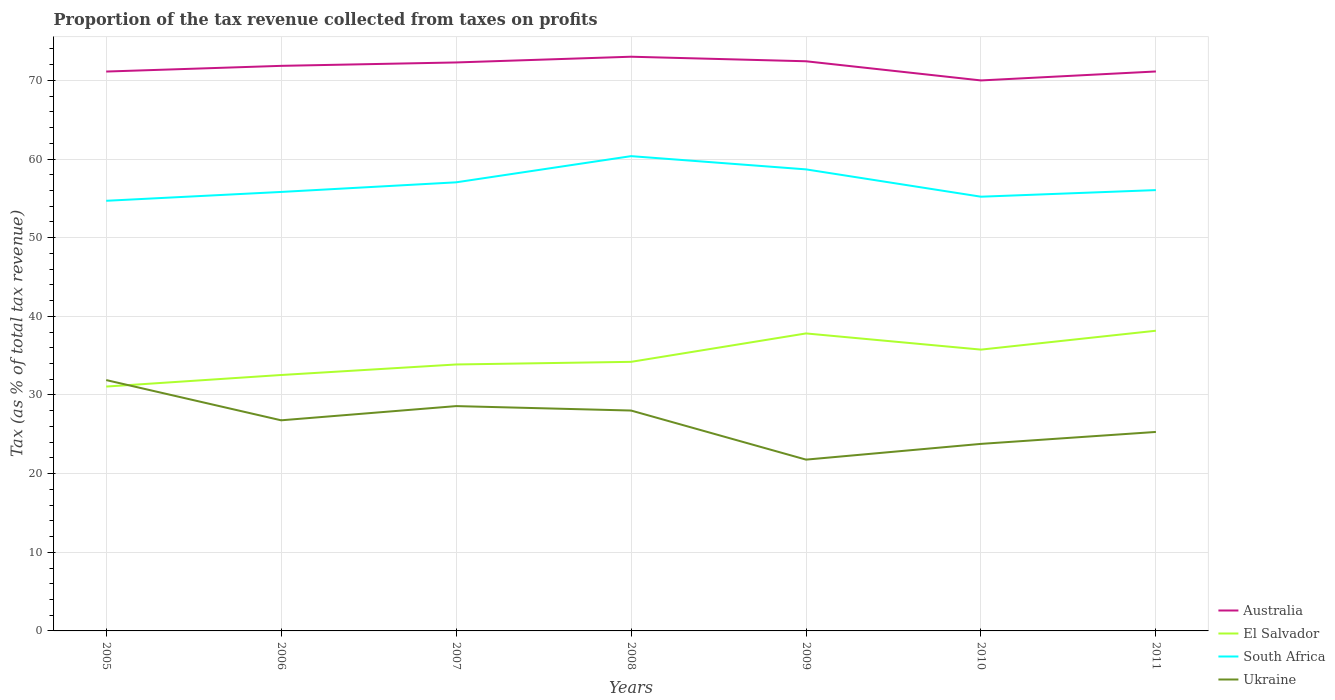How many different coloured lines are there?
Your answer should be very brief. 4. Across all years, what is the maximum proportion of the tax revenue collected in Australia?
Provide a succinct answer. 70. What is the total proportion of the tax revenue collected in El Salvador in the graph?
Your response must be concise. -5.63. What is the difference between the highest and the second highest proportion of the tax revenue collected in Australia?
Your answer should be compact. 3.01. Is the proportion of the tax revenue collected in Australia strictly greater than the proportion of the tax revenue collected in Ukraine over the years?
Your answer should be compact. No. Are the values on the major ticks of Y-axis written in scientific E-notation?
Provide a succinct answer. No. Does the graph contain grids?
Offer a very short reply. Yes. What is the title of the graph?
Your answer should be compact. Proportion of the tax revenue collected from taxes on profits. Does "Cabo Verde" appear as one of the legend labels in the graph?
Make the answer very short. No. What is the label or title of the Y-axis?
Your answer should be compact. Tax (as % of total tax revenue). What is the Tax (as % of total tax revenue) of Australia in 2005?
Keep it short and to the point. 71.13. What is the Tax (as % of total tax revenue) in El Salvador in 2005?
Make the answer very short. 31.07. What is the Tax (as % of total tax revenue) in South Africa in 2005?
Keep it short and to the point. 54.69. What is the Tax (as % of total tax revenue) in Ukraine in 2005?
Provide a succinct answer. 31.9. What is the Tax (as % of total tax revenue) of Australia in 2006?
Make the answer very short. 71.85. What is the Tax (as % of total tax revenue) of El Salvador in 2006?
Your answer should be compact. 32.54. What is the Tax (as % of total tax revenue) of South Africa in 2006?
Your answer should be compact. 55.82. What is the Tax (as % of total tax revenue) of Ukraine in 2006?
Keep it short and to the point. 26.78. What is the Tax (as % of total tax revenue) of Australia in 2007?
Provide a succinct answer. 72.28. What is the Tax (as % of total tax revenue) of El Salvador in 2007?
Provide a short and direct response. 33.88. What is the Tax (as % of total tax revenue) of South Africa in 2007?
Offer a terse response. 57.04. What is the Tax (as % of total tax revenue) in Ukraine in 2007?
Offer a terse response. 28.59. What is the Tax (as % of total tax revenue) in Australia in 2008?
Provide a short and direct response. 73.01. What is the Tax (as % of total tax revenue) in El Salvador in 2008?
Offer a terse response. 34.21. What is the Tax (as % of total tax revenue) in South Africa in 2008?
Ensure brevity in your answer.  60.37. What is the Tax (as % of total tax revenue) of Ukraine in 2008?
Your answer should be very brief. 28.02. What is the Tax (as % of total tax revenue) in Australia in 2009?
Offer a terse response. 72.43. What is the Tax (as % of total tax revenue) of El Salvador in 2009?
Offer a terse response. 37.83. What is the Tax (as % of total tax revenue) in South Africa in 2009?
Your answer should be very brief. 58.69. What is the Tax (as % of total tax revenue) of Ukraine in 2009?
Your answer should be compact. 21.78. What is the Tax (as % of total tax revenue) in Australia in 2010?
Offer a terse response. 70. What is the Tax (as % of total tax revenue) of El Salvador in 2010?
Give a very brief answer. 35.77. What is the Tax (as % of total tax revenue) in South Africa in 2010?
Provide a short and direct response. 55.21. What is the Tax (as % of total tax revenue) in Ukraine in 2010?
Your response must be concise. 23.78. What is the Tax (as % of total tax revenue) in Australia in 2011?
Ensure brevity in your answer.  71.14. What is the Tax (as % of total tax revenue) of El Salvador in 2011?
Provide a succinct answer. 38.17. What is the Tax (as % of total tax revenue) of South Africa in 2011?
Your answer should be compact. 56.05. What is the Tax (as % of total tax revenue) of Ukraine in 2011?
Give a very brief answer. 25.3. Across all years, what is the maximum Tax (as % of total tax revenue) in Australia?
Provide a succinct answer. 73.01. Across all years, what is the maximum Tax (as % of total tax revenue) of El Salvador?
Keep it short and to the point. 38.17. Across all years, what is the maximum Tax (as % of total tax revenue) of South Africa?
Your response must be concise. 60.37. Across all years, what is the maximum Tax (as % of total tax revenue) in Ukraine?
Your response must be concise. 31.9. Across all years, what is the minimum Tax (as % of total tax revenue) in Australia?
Provide a succinct answer. 70. Across all years, what is the minimum Tax (as % of total tax revenue) in El Salvador?
Keep it short and to the point. 31.07. Across all years, what is the minimum Tax (as % of total tax revenue) of South Africa?
Offer a very short reply. 54.69. Across all years, what is the minimum Tax (as % of total tax revenue) in Ukraine?
Your answer should be very brief. 21.78. What is the total Tax (as % of total tax revenue) in Australia in the graph?
Your answer should be compact. 501.84. What is the total Tax (as % of total tax revenue) in El Salvador in the graph?
Make the answer very short. 243.48. What is the total Tax (as % of total tax revenue) in South Africa in the graph?
Provide a short and direct response. 397.88. What is the total Tax (as % of total tax revenue) in Ukraine in the graph?
Your answer should be compact. 186.15. What is the difference between the Tax (as % of total tax revenue) of Australia in 2005 and that in 2006?
Provide a succinct answer. -0.72. What is the difference between the Tax (as % of total tax revenue) in El Salvador in 2005 and that in 2006?
Your answer should be very brief. -1.47. What is the difference between the Tax (as % of total tax revenue) in South Africa in 2005 and that in 2006?
Make the answer very short. -1.13. What is the difference between the Tax (as % of total tax revenue) in Ukraine in 2005 and that in 2006?
Ensure brevity in your answer.  5.12. What is the difference between the Tax (as % of total tax revenue) of Australia in 2005 and that in 2007?
Provide a short and direct response. -1.16. What is the difference between the Tax (as % of total tax revenue) of El Salvador in 2005 and that in 2007?
Offer a very short reply. -2.81. What is the difference between the Tax (as % of total tax revenue) in South Africa in 2005 and that in 2007?
Offer a very short reply. -2.35. What is the difference between the Tax (as % of total tax revenue) in Ukraine in 2005 and that in 2007?
Make the answer very short. 3.31. What is the difference between the Tax (as % of total tax revenue) in Australia in 2005 and that in 2008?
Give a very brief answer. -1.89. What is the difference between the Tax (as % of total tax revenue) in El Salvador in 2005 and that in 2008?
Provide a succinct answer. -3.14. What is the difference between the Tax (as % of total tax revenue) of South Africa in 2005 and that in 2008?
Offer a very short reply. -5.68. What is the difference between the Tax (as % of total tax revenue) in Ukraine in 2005 and that in 2008?
Provide a short and direct response. 3.87. What is the difference between the Tax (as % of total tax revenue) in Australia in 2005 and that in 2009?
Provide a short and direct response. -1.31. What is the difference between the Tax (as % of total tax revenue) of El Salvador in 2005 and that in 2009?
Your answer should be very brief. -6.76. What is the difference between the Tax (as % of total tax revenue) in South Africa in 2005 and that in 2009?
Your answer should be compact. -3.99. What is the difference between the Tax (as % of total tax revenue) in Ukraine in 2005 and that in 2009?
Offer a terse response. 10.12. What is the difference between the Tax (as % of total tax revenue) in Australia in 2005 and that in 2010?
Make the answer very short. 1.13. What is the difference between the Tax (as % of total tax revenue) of El Salvador in 2005 and that in 2010?
Make the answer very short. -4.7. What is the difference between the Tax (as % of total tax revenue) of South Africa in 2005 and that in 2010?
Make the answer very short. -0.52. What is the difference between the Tax (as % of total tax revenue) of Ukraine in 2005 and that in 2010?
Ensure brevity in your answer.  8.11. What is the difference between the Tax (as % of total tax revenue) of Australia in 2005 and that in 2011?
Keep it short and to the point. -0.01. What is the difference between the Tax (as % of total tax revenue) in El Salvador in 2005 and that in 2011?
Give a very brief answer. -7.1. What is the difference between the Tax (as % of total tax revenue) in South Africa in 2005 and that in 2011?
Offer a very short reply. -1.36. What is the difference between the Tax (as % of total tax revenue) in Ukraine in 2005 and that in 2011?
Ensure brevity in your answer.  6.6. What is the difference between the Tax (as % of total tax revenue) of Australia in 2006 and that in 2007?
Ensure brevity in your answer.  -0.43. What is the difference between the Tax (as % of total tax revenue) of El Salvador in 2006 and that in 2007?
Ensure brevity in your answer.  -1.34. What is the difference between the Tax (as % of total tax revenue) of South Africa in 2006 and that in 2007?
Offer a very short reply. -1.22. What is the difference between the Tax (as % of total tax revenue) of Ukraine in 2006 and that in 2007?
Your answer should be very brief. -1.81. What is the difference between the Tax (as % of total tax revenue) of Australia in 2006 and that in 2008?
Make the answer very short. -1.16. What is the difference between the Tax (as % of total tax revenue) of El Salvador in 2006 and that in 2008?
Provide a succinct answer. -1.67. What is the difference between the Tax (as % of total tax revenue) of South Africa in 2006 and that in 2008?
Your answer should be compact. -4.55. What is the difference between the Tax (as % of total tax revenue) of Ukraine in 2006 and that in 2008?
Give a very brief answer. -1.24. What is the difference between the Tax (as % of total tax revenue) in Australia in 2006 and that in 2009?
Give a very brief answer. -0.58. What is the difference between the Tax (as % of total tax revenue) in El Salvador in 2006 and that in 2009?
Provide a succinct answer. -5.28. What is the difference between the Tax (as % of total tax revenue) of South Africa in 2006 and that in 2009?
Your answer should be compact. -2.87. What is the difference between the Tax (as % of total tax revenue) in Ukraine in 2006 and that in 2009?
Your answer should be very brief. 5. What is the difference between the Tax (as % of total tax revenue) of Australia in 2006 and that in 2010?
Keep it short and to the point. 1.85. What is the difference between the Tax (as % of total tax revenue) in El Salvador in 2006 and that in 2010?
Give a very brief answer. -3.23. What is the difference between the Tax (as % of total tax revenue) of South Africa in 2006 and that in 2010?
Your response must be concise. 0.61. What is the difference between the Tax (as % of total tax revenue) of Ukraine in 2006 and that in 2010?
Your answer should be very brief. 3. What is the difference between the Tax (as % of total tax revenue) in Australia in 2006 and that in 2011?
Provide a succinct answer. 0.71. What is the difference between the Tax (as % of total tax revenue) in El Salvador in 2006 and that in 2011?
Keep it short and to the point. -5.63. What is the difference between the Tax (as % of total tax revenue) in South Africa in 2006 and that in 2011?
Your answer should be compact. -0.23. What is the difference between the Tax (as % of total tax revenue) in Ukraine in 2006 and that in 2011?
Provide a short and direct response. 1.48. What is the difference between the Tax (as % of total tax revenue) in Australia in 2007 and that in 2008?
Provide a succinct answer. -0.73. What is the difference between the Tax (as % of total tax revenue) of El Salvador in 2007 and that in 2008?
Ensure brevity in your answer.  -0.33. What is the difference between the Tax (as % of total tax revenue) in South Africa in 2007 and that in 2008?
Your answer should be compact. -3.33. What is the difference between the Tax (as % of total tax revenue) of Ukraine in 2007 and that in 2008?
Give a very brief answer. 0.56. What is the difference between the Tax (as % of total tax revenue) of Australia in 2007 and that in 2009?
Offer a very short reply. -0.15. What is the difference between the Tax (as % of total tax revenue) of El Salvador in 2007 and that in 2009?
Provide a short and direct response. -3.95. What is the difference between the Tax (as % of total tax revenue) of South Africa in 2007 and that in 2009?
Ensure brevity in your answer.  -1.65. What is the difference between the Tax (as % of total tax revenue) in Ukraine in 2007 and that in 2009?
Keep it short and to the point. 6.81. What is the difference between the Tax (as % of total tax revenue) of Australia in 2007 and that in 2010?
Your answer should be compact. 2.29. What is the difference between the Tax (as % of total tax revenue) of El Salvador in 2007 and that in 2010?
Make the answer very short. -1.89. What is the difference between the Tax (as % of total tax revenue) in South Africa in 2007 and that in 2010?
Make the answer very short. 1.83. What is the difference between the Tax (as % of total tax revenue) of Ukraine in 2007 and that in 2010?
Keep it short and to the point. 4.8. What is the difference between the Tax (as % of total tax revenue) in Australia in 2007 and that in 2011?
Your answer should be compact. 1.15. What is the difference between the Tax (as % of total tax revenue) in El Salvador in 2007 and that in 2011?
Give a very brief answer. -4.29. What is the difference between the Tax (as % of total tax revenue) of South Africa in 2007 and that in 2011?
Your response must be concise. 0.99. What is the difference between the Tax (as % of total tax revenue) of Ukraine in 2007 and that in 2011?
Ensure brevity in your answer.  3.29. What is the difference between the Tax (as % of total tax revenue) in Australia in 2008 and that in 2009?
Give a very brief answer. 0.58. What is the difference between the Tax (as % of total tax revenue) in El Salvador in 2008 and that in 2009?
Ensure brevity in your answer.  -3.61. What is the difference between the Tax (as % of total tax revenue) of South Africa in 2008 and that in 2009?
Keep it short and to the point. 1.68. What is the difference between the Tax (as % of total tax revenue) in Ukraine in 2008 and that in 2009?
Offer a terse response. 6.24. What is the difference between the Tax (as % of total tax revenue) of Australia in 2008 and that in 2010?
Ensure brevity in your answer.  3.01. What is the difference between the Tax (as % of total tax revenue) in El Salvador in 2008 and that in 2010?
Your answer should be compact. -1.56. What is the difference between the Tax (as % of total tax revenue) in South Africa in 2008 and that in 2010?
Provide a short and direct response. 5.16. What is the difference between the Tax (as % of total tax revenue) of Ukraine in 2008 and that in 2010?
Provide a succinct answer. 4.24. What is the difference between the Tax (as % of total tax revenue) of Australia in 2008 and that in 2011?
Give a very brief answer. 1.87. What is the difference between the Tax (as % of total tax revenue) of El Salvador in 2008 and that in 2011?
Provide a succinct answer. -3.96. What is the difference between the Tax (as % of total tax revenue) in South Africa in 2008 and that in 2011?
Your answer should be compact. 4.32. What is the difference between the Tax (as % of total tax revenue) in Ukraine in 2008 and that in 2011?
Your answer should be very brief. 2.72. What is the difference between the Tax (as % of total tax revenue) of Australia in 2009 and that in 2010?
Your response must be concise. 2.44. What is the difference between the Tax (as % of total tax revenue) of El Salvador in 2009 and that in 2010?
Provide a succinct answer. 2.06. What is the difference between the Tax (as % of total tax revenue) in South Africa in 2009 and that in 2010?
Offer a very short reply. 3.47. What is the difference between the Tax (as % of total tax revenue) of Ukraine in 2009 and that in 2010?
Your answer should be very brief. -2. What is the difference between the Tax (as % of total tax revenue) of Australia in 2009 and that in 2011?
Your answer should be compact. 1.3. What is the difference between the Tax (as % of total tax revenue) of El Salvador in 2009 and that in 2011?
Offer a very short reply. -0.34. What is the difference between the Tax (as % of total tax revenue) in South Africa in 2009 and that in 2011?
Provide a succinct answer. 2.63. What is the difference between the Tax (as % of total tax revenue) of Ukraine in 2009 and that in 2011?
Make the answer very short. -3.52. What is the difference between the Tax (as % of total tax revenue) in Australia in 2010 and that in 2011?
Your answer should be very brief. -1.14. What is the difference between the Tax (as % of total tax revenue) in El Salvador in 2010 and that in 2011?
Keep it short and to the point. -2.4. What is the difference between the Tax (as % of total tax revenue) in South Africa in 2010 and that in 2011?
Offer a terse response. -0.84. What is the difference between the Tax (as % of total tax revenue) in Ukraine in 2010 and that in 2011?
Ensure brevity in your answer.  -1.52. What is the difference between the Tax (as % of total tax revenue) of Australia in 2005 and the Tax (as % of total tax revenue) of El Salvador in 2006?
Provide a succinct answer. 38.58. What is the difference between the Tax (as % of total tax revenue) in Australia in 2005 and the Tax (as % of total tax revenue) in South Africa in 2006?
Make the answer very short. 15.31. What is the difference between the Tax (as % of total tax revenue) of Australia in 2005 and the Tax (as % of total tax revenue) of Ukraine in 2006?
Keep it short and to the point. 44.35. What is the difference between the Tax (as % of total tax revenue) in El Salvador in 2005 and the Tax (as % of total tax revenue) in South Africa in 2006?
Your response must be concise. -24.75. What is the difference between the Tax (as % of total tax revenue) of El Salvador in 2005 and the Tax (as % of total tax revenue) of Ukraine in 2006?
Your answer should be compact. 4.29. What is the difference between the Tax (as % of total tax revenue) in South Africa in 2005 and the Tax (as % of total tax revenue) in Ukraine in 2006?
Ensure brevity in your answer.  27.91. What is the difference between the Tax (as % of total tax revenue) of Australia in 2005 and the Tax (as % of total tax revenue) of El Salvador in 2007?
Keep it short and to the point. 37.25. What is the difference between the Tax (as % of total tax revenue) in Australia in 2005 and the Tax (as % of total tax revenue) in South Africa in 2007?
Ensure brevity in your answer.  14.09. What is the difference between the Tax (as % of total tax revenue) of Australia in 2005 and the Tax (as % of total tax revenue) of Ukraine in 2007?
Offer a terse response. 42.54. What is the difference between the Tax (as % of total tax revenue) of El Salvador in 2005 and the Tax (as % of total tax revenue) of South Africa in 2007?
Give a very brief answer. -25.97. What is the difference between the Tax (as % of total tax revenue) of El Salvador in 2005 and the Tax (as % of total tax revenue) of Ukraine in 2007?
Offer a very short reply. 2.48. What is the difference between the Tax (as % of total tax revenue) of South Africa in 2005 and the Tax (as % of total tax revenue) of Ukraine in 2007?
Provide a succinct answer. 26.11. What is the difference between the Tax (as % of total tax revenue) of Australia in 2005 and the Tax (as % of total tax revenue) of El Salvador in 2008?
Offer a terse response. 36.91. What is the difference between the Tax (as % of total tax revenue) of Australia in 2005 and the Tax (as % of total tax revenue) of South Africa in 2008?
Give a very brief answer. 10.76. What is the difference between the Tax (as % of total tax revenue) in Australia in 2005 and the Tax (as % of total tax revenue) in Ukraine in 2008?
Offer a very short reply. 43.1. What is the difference between the Tax (as % of total tax revenue) of El Salvador in 2005 and the Tax (as % of total tax revenue) of South Africa in 2008?
Ensure brevity in your answer.  -29.3. What is the difference between the Tax (as % of total tax revenue) in El Salvador in 2005 and the Tax (as % of total tax revenue) in Ukraine in 2008?
Your answer should be very brief. 3.05. What is the difference between the Tax (as % of total tax revenue) in South Africa in 2005 and the Tax (as % of total tax revenue) in Ukraine in 2008?
Keep it short and to the point. 26.67. What is the difference between the Tax (as % of total tax revenue) in Australia in 2005 and the Tax (as % of total tax revenue) in El Salvador in 2009?
Your response must be concise. 33.3. What is the difference between the Tax (as % of total tax revenue) in Australia in 2005 and the Tax (as % of total tax revenue) in South Africa in 2009?
Keep it short and to the point. 12.44. What is the difference between the Tax (as % of total tax revenue) of Australia in 2005 and the Tax (as % of total tax revenue) of Ukraine in 2009?
Your answer should be very brief. 49.35. What is the difference between the Tax (as % of total tax revenue) in El Salvador in 2005 and the Tax (as % of total tax revenue) in South Africa in 2009?
Offer a very short reply. -27.62. What is the difference between the Tax (as % of total tax revenue) of El Salvador in 2005 and the Tax (as % of total tax revenue) of Ukraine in 2009?
Your response must be concise. 9.29. What is the difference between the Tax (as % of total tax revenue) of South Africa in 2005 and the Tax (as % of total tax revenue) of Ukraine in 2009?
Provide a succinct answer. 32.91. What is the difference between the Tax (as % of total tax revenue) in Australia in 2005 and the Tax (as % of total tax revenue) in El Salvador in 2010?
Your answer should be compact. 35.36. What is the difference between the Tax (as % of total tax revenue) of Australia in 2005 and the Tax (as % of total tax revenue) of South Africa in 2010?
Your answer should be compact. 15.91. What is the difference between the Tax (as % of total tax revenue) of Australia in 2005 and the Tax (as % of total tax revenue) of Ukraine in 2010?
Provide a short and direct response. 47.34. What is the difference between the Tax (as % of total tax revenue) in El Salvador in 2005 and the Tax (as % of total tax revenue) in South Africa in 2010?
Give a very brief answer. -24.14. What is the difference between the Tax (as % of total tax revenue) of El Salvador in 2005 and the Tax (as % of total tax revenue) of Ukraine in 2010?
Offer a terse response. 7.29. What is the difference between the Tax (as % of total tax revenue) of South Africa in 2005 and the Tax (as % of total tax revenue) of Ukraine in 2010?
Give a very brief answer. 30.91. What is the difference between the Tax (as % of total tax revenue) in Australia in 2005 and the Tax (as % of total tax revenue) in El Salvador in 2011?
Provide a succinct answer. 32.96. What is the difference between the Tax (as % of total tax revenue) in Australia in 2005 and the Tax (as % of total tax revenue) in South Africa in 2011?
Provide a succinct answer. 15.07. What is the difference between the Tax (as % of total tax revenue) in Australia in 2005 and the Tax (as % of total tax revenue) in Ukraine in 2011?
Make the answer very short. 45.83. What is the difference between the Tax (as % of total tax revenue) in El Salvador in 2005 and the Tax (as % of total tax revenue) in South Africa in 2011?
Keep it short and to the point. -24.98. What is the difference between the Tax (as % of total tax revenue) of El Salvador in 2005 and the Tax (as % of total tax revenue) of Ukraine in 2011?
Give a very brief answer. 5.77. What is the difference between the Tax (as % of total tax revenue) of South Africa in 2005 and the Tax (as % of total tax revenue) of Ukraine in 2011?
Provide a succinct answer. 29.39. What is the difference between the Tax (as % of total tax revenue) of Australia in 2006 and the Tax (as % of total tax revenue) of El Salvador in 2007?
Provide a short and direct response. 37.97. What is the difference between the Tax (as % of total tax revenue) of Australia in 2006 and the Tax (as % of total tax revenue) of South Africa in 2007?
Ensure brevity in your answer.  14.81. What is the difference between the Tax (as % of total tax revenue) of Australia in 2006 and the Tax (as % of total tax revenue) of Ukraine in 2007?
Your answer should be compact. 43.26. What is the difference between the Tax (as % of total tax revenue) in El Salvador in 2006 and the Tax (as % of total tax revenue) in South Africa in 2007?
Provide a succinct answer. -24.5. What is the difference between the Tax (as % of total tax revenue) in El Salvador in 2006 and the Tax (as % of total tax revenue) in Ukraine in 2007?
Make the answer very short. 3.96. What is the difference between the Tax (as % of total tax revenue) of South Africa in 2006 and the Tax (as % of total tax revenue) of Ukraine in 2007?
Give a very brief answer. 27.23. What is the difference between the Tax (as % of total tax revenue) in Australia in 2006 and the Tax (as % of total tax revenue) in El Salvador in 2008?
Keep it short and to the point. 37.64. What is the difference between the Tax (as % of total tax revenue) of Australia in 2006 and the Tax (as % of total tax revenue) of South Africa in 2008?
Provide a short and direct response. 11.48. What is the difference between the Tax (as % of total tax revenue) of Australia in 2006 and the Tax (as % of total tax revenue) of Ukraine in 2008?
Make the answer very short. 43.83. What is the difference between the Tax (as % of total tax revenue) of El Salvador in 2006 and the Tax (as % of total tax revenue) of South Africa in 2008?
Your response must be concise. -27.83. What is the difference between the Tax (as % of total tax revenue) in El Salvador in 2006 and the Tax (as % of total tax revenue) in Ukraine in 2008?
Your response must be concise. 4.52. What is the difference between the Tax (as % of total tax revenue) in South Africa in 2006 and the Tax (as % of total tax revenue) in Ukraine in 2008?
Your response must be concise. 27.8. What is the difference between the Tax (as % of total tax revenue) in Australia in 2006 and the Tax (as % of total tax revenue) in El Salvador in 2009?
Offer a very short reply. 34.02. What is the difference between the Tax (as % of total tax revenue) of Australia in 2006 and the Tax (as % of total tax revenue) of South Africa in 2009?
Give a very brief answer. 13.16. What is the difference between the Tax (as % of total tax revenue) of Australia in 2006 and the Tax (as % of total tax revenue) of Ukraine in 2009?
Your response must be concise. 50.07. What is the difference between the Tax (as % of total tax revenue) of El Salvador in 2006 and the Tax (as % of total tax revenue) of South Africa in 2009?
Offer a terse response. -26.15. What is the difference between the Tax (as % of total tax revenue) in El Salvador in 2006 and the Tax (as % of total tax revenue) in Ukraine in 2009?
Keep it short and to the point. 10.76. What is the difference between the Tax (as % of total tax revenue) in South Africa in 2006 and the Tax (as % of total tax revenue) in Ukraine in 2009?
Your response must be concise. 34.04. What is the difference between the Tax (as % of total tax revenue) in Australia in 2006 and the Tax (as % of total tax revenue) in El Salvador in 2010?
Your answer should be compact. 36.08. What is the difference between the Tax (as % of total tax revenue) in Australia in 2006 and the Tax (as % of total tax revenue) in South Africa in 2010?
Keep it short and to the point. 16.64. What is the difference between the Tax (as % of total tax revenue) of Australia in 2006 and the Tax (as % of total tax revenue) of Ukraine in 2010?
Provide a succinct answer. 48.07. What is the difference between the Tax (as % of total tax revenue) of El Salvador in 2006 and the Tax (as % of total tax revenue) of South Africa in 2010?
Your answer should be compact. -22.67. What is the difference between the Tax (as % of total tax revenue) in El Salvador in 2006 and the Tax (as % of total tax revenue) in Ukraine in 2010?
Offer a very short reply. 8.76. What is the difference between the Tax (as % of total tax revenue) in South Africa in 2006 and the Tax (as % of total tax revenue) in Ukraine in 2010?
Your answer should be very brief. 32.04. What is the difference between the Tax (as % of total tax revenue) in Australia in 2006 and the Tax (as % of total tax revenue) in El Salvador in 2011?
Provide a short and direct response. 33.68. What is the difference between the Tax (as % of total tax revenue) of Australia in 2006 and the Tax (as % of total tax revenue) of South Africa in 2011?
Your answer should be very brief. 15.8. What is the difference between the Tax (as % of total tax revenue) in Australia in 2006 and the Tax (as % of total tax revenue) in Ukraine in 2011?
Keep it short and to the point. 46.55. What is the difference between the Tax (as % of total tax revenue) in El Salvador in 2006 and the Tax (as % of total tax revenue) in South Africa in 2011?
Ensure brevity in your answer.  -23.51. What is the difference between the Tax (as % of total tax revenue) in El Salvador in 2006 and the Tax (as % of total tax revenue) in Ukraine in 2011?
Ensure brevity in your answer.  7.24. What is the difference between the Tax (as % of total tax revenue) in South Africa in 2006 and the Tax (as % of total tax revenue) in Ukraine in 2011?
Provide a succinct answer. 30.52. What is the difference between the Tax (as % of total tax revenue) of Australia in 2007 and the Tax (as % of total tax revenue) of El Salvador in 2008?
Provide a short and direct response. 38.07. What is the difference between the Tax (as % of total tax revenue) in Australia in 2007 and the Tax (as % of total tax revenue) in South Africa in 2008?
Keep it short and to the point. 11.91. What is the difference between the Tax (as % of total tax revenue) in Australia in 2007 and the Tax (as % of total tax revenue) in Ukraine in 2008?
Offer a very short reply. 44.26. What is the difference between the Tax (as % of total tax revenue) of El Salvador in 2007 and the Tax (as % of total tax revenue) of South Africa in 2008?
Offer a terse response. -26.49. What is the difference between the Tax (as % of total tax revenue) of El Salvador in 2007 and the Tax (as % of total tax revenue) of Ukraine in 2008?
Your response must be concise. 5.86. What is the difference between the Tax (as % of total tax revenue) of South Africa in 2007 and the Tax (as % of total tax revenue) of Ukraine in 2008?
Your response must be concise. 29.02. What is the difference between the Tax (as % of total tax revenue) of Australia in 2007 and the Tax (as % of total tax revenue) of El Salvador in 2009?
Provide a short and direct response. 34.46. What is the difference between the Tax (as % of total tax revenue) of Australia in 2007 and the Tax (as % of total tax revenue) of South Africa in 2009?
Your answer should be compact. 13.6. What is the difference between the Tax (as % of total tax revenue) of Australia in 2007 and the Tax (as % of total tax revenue) of Ukraine in 2009?
Your response must be concise. 50.5. What is the difference between the Tax (as % of total tax revenue) of El Salvador in 2007 and the Tax (as % of total tax revenue) of South Africa in 2009?
Make the answer very short. -24.81. What is the difference between the Tax (as % of total tax revenue) in El Salvador in 2007 and the Tax (as % of total tax revenue) in Ukraine in 2009?
Make the answer very short. 12.1. What is the difference between the Tax (as % of total tax revenue) in South Africa in 2007 and the Tax (as % of total tax revenue) in Ukraine in 2009?
Make the answer very short. 35.26. What is the difference between the Tax (as % of total tax revenue) in Australia in 2007 and the Tax (as % of total tax revenue) in El Salvador in 2010?
Make the answer very short. 36.51. What is the difference between the Tax (as % of total tax revenue) of Australia in 2007 and the Tax (as % of total tax revenue) of South Africa in 2010?
Provide a short and direct response. 17.07. What is the difference between the Tax (as % of total tax revenue) of Australia in 2007 and the Tax (as % of total tax revenue) of Ukraine in 2010?
Provide a short and direct response. 48.5. What is the difference between the Tax (as % of total tax revenue) of El Salvador in 2007 and the Tax (as % of total tax revenue) of South Africa in 2010?
Keep it short and to the point. -21.33. What is the difference between the Tax (as % of total tax revenue) of El Salvador in 2007 and the Tax (as % of total tax revenue) of Ukraine in 2010?
Keep it short and to the point. 10.1. What is the difference between the Tax (as % of total tax revenue) in South Africa in 2007 and the Tax (as % of total tax revenue) in Ukraine in 2010?
Offer a terse response. 33.26. What is the difference between the Tax (as % of total tax revenue) in Australia in 2007 and the Tax (as % of total tax revenue) in El Salvador in 2011?
Offer a very short reply. 34.11. What is the difference between the Tax (as % of total tax revenue) of Australia in 2007 and the Tax (as % of total tax revenue) of South Africa in 2011?
Your answer should be very brief. 16.23. What is the difference between the Tax (as % of total tax revenue) in Australia in 2007 and the Tax (as % of total tax revenue) in Ukraine in 2011?
Keep it short and to the point. 46.98. What is the difference between the Tax (as % of total tax revenue) in El Salvador in 2007 and the Tax (as % of total tax revenue) in South Africa in 2011?
Provide a succinct answer. -22.17. What is the difference between the Tax (as % of total tax revenue) in El Salvador in 2007 and the Tax (as % of total tax revenue) in Ukraine in 2011?
Give a very brief answer. 8.58. What is the difference between the Tax (as % of total tax revenue) of South Africa in 2007 and the Tax (as % of total tax revenue) of Ukraine in 2011?
Your answer should be compact. 31.74. What is the difference between the Tax (as % of total tax revenue) in Australia in 2008 and the Tax (as % of total tax revenue) in El Salvador in 2009?
Offer a terse response. 35.19. What is the difference between the Tax (as % of total tax revenue) of Australia in 2008 and the Tax (as % of total tax revenue) of South Africa in 2009?
Provide a short and direct response. 14.32. What is the difference between the Tax (as % of total tax revenue) of Australia in 2008 and the Tax (as % of total tax revenue) of Ukraine in 2009?
Keep it short and to the point. 51.23. What is the difference between the Tax (as % of total tax revenue) of El Salvador in 2008 and the Tax (as % of total tax revenue) of South Africa in 2009?
Offer a very short reply. -24.47. What is the difference between the Tax (as % of total tax revenue) of El Salvador in 2008 and the Tax (as % of total tax revenue) of Ukraine in 2009?
Give a very brief answer. 12.43. What is the difference between the Tax (as % of total tax revenue) of South Africa in 2008 and the Tax (as % of total tax revenue) of Ukraine in 2009?
Offer a terse response. 38.59. What is the difference between the Tax (as % of total tax revenue) of Australia in 2008 and the Tax (as % of total tax revenue) of El Salvador in 2010?
Give a very brief answer. 37.24. What is the difference between the Tax (as % of total tax revenue) in Australia in 2008 and the Tax (as % of total tax revenue) in South Africa in 2010?
Ensure brevity in your answer.  17.8. What is the difference between the Tax (as % of total tax revenue) in Australia in 2008 and the Tax (as % of total tax revenue) in Ukraine in 2010?
Your response must be concise. 49.23. What is the difference between the Tax (as % of total tax revenue) of El Salvador in 2008 and the Tax (as % of total tax revenue) of South Africa in 2010?
Your answer should be compact. -21. What is the difference between the Tax (as % of total tax revenue) in El Salvador in 2008 and the Tax (as % of total tax revenue) in Ukraine in 2010?
Make the answer very short. 10.43. What is the difference between the Tax (as % of total tax revenue) in South Africa in 2008 and the Tax (as % of total tax revenue) in Ukraine in 2010?
Your answer should be compact. 36.59. What is the difference between the Tax (as % of total tax revenue) of Australia in 2008 and the Tax (as % of total tax revenue) of El Salvador in 2011?
Give a very brief answer. 34.84. What is the difference between the Tax (as % of total tax revenue) in Australia in 2008 and the Tax (as % of total tax revenue) in South Africa in 2011?
Provide a succinct answer. 16.96. What is the difference between the Tax (as % of total tax revenue) of Australia in 2008 and the Tax (as % of total tax revenue) of Ukraine in 2011?
Provide a short and direct response. 47.71. What is the difference between the Tax (as % of total tax revenue) in El Salvador in 2008 and the Tax (as % of total tax revenue) in South Africa in 2011?
Make the answer very short. -21.84. What is the difference between the Tax (as % of total tax revenue) in El Salvador in 2008 and the Tax (as % of total tax revenue) in Ukraine in 2011?
Your response must be concise. 8.91. What is the difference between the Tax (as % of total tax revenue) of South Africa in 2008 and the Tax (as % of total tax revenue) of Ukraine in 2011?
Give a very brief answer. 35.07. What is the difference between the Tax (as % of total tax revenue) in Australia in 2009 and the Tax (as % of total tax revenue) in El Salvador in 2010?
Give a very brief answer. 36.66. What is the difference between the Tax (as % of total tax revenue) in Australia in 2009 and the Tax (as % of total tax revenue) in South Africa in 2010?
Ensure brevity in your answer.  17.22. What is the difference between the Tax (as % of total tax revenue) in Australia in 2009 and the Tax (as % of total tax revenue) in Ukraine in 2010?
Give a very brief answer. 48.65. What is the difference between the Tax (as % of total tax revenue) in El Salvador in 2009 and the Tax (as % of total tax revenue) in South Africa in 2010?
Ensure brevity in your answer.  -17.39. What is the difference between the Tax (as % of total tax revenue) of El Salvador in 2009 and the Tax (as % of total tax revenue) of Ukraine in 2010?
Keep it short and to the point. 14.04. What is the difference between the Tax (as % of total tax revenue) of South Africa in 2009 and the Tax (as % of total tax revenue) of Ukraine in 2010?
Make the answer very short. 34.9. What is the difference between the Tax (as % of total tax revenue) of Australia in 2009 and the Tax (as % of total tax revenue) of El Salvador in 2011?
Provide a succinct answer. 34.26. What is the difference between the Tax (as % of total tax revenue) of Australia in 2009 and the Tax (as % of total tax revenue) of South Africa in 2011?
Give a very brief answer. 16.38. What is the difference between the Tax (as % of total tax revenue) of Australia in 2009 and the Tax (as % of total tax revenue) of Ukraine in 2011?
Give a very brief answer. 47.13. What is the difference between the Tax (as % of total tax revenue) of El Salvador in 2009 and the Tax (as % of total tax revenue) of South Africa in 2011?
Provide a short and direct response. -18.23. What is the difference between the Tax (as % of total tax revenue) in El Salvador in 2009 and the Tax (as % of total tax revenue) in Ukraine in 2011?
Your answer should be very brief. 12.53. What is the difference between the Tax (as % of total tax revenue) in South Africa in 2009 and the Tax (as % of total tax revenue) in Ukraine in 2011?
Make the answer very short. 33.39. What is the difference between the Tax (as % of total tax revenue) of Australia in 2010 and the Tax (as % of total tax revenue) of El Salvador in 2011?
Give a very brief answer. 31.83. What is the difference between the Tax (as % of total tax revenue) of Australia in 2010 and the Tax (as % of total tax revenue) of South Africa in 2011?
Give a very brief answer. 13.95. What is the difference between the Tax (as % of total tax revenue) of Australia in 2010 and the Tax (as % of total tax revenue) of Ukraine in 2011?
Ensure brevity in your answer.  44.7. What is the difference between the Tax (as % of total tax revenue) in El Salvador in 2010 and the Tax (as % of total tax revenue) in South Africa in 2011?
Provide a succinct answer. -20.28. What is the difference between the Tax (as % of total tax revenue) in El Salvador in 2010 and the Tax (as % of total tax revenue) in Ukraine in 2011?
Your response must be concise. 10.47. What is the difference between the Tax (as % of total tax revenue) of South Africa in 2010 and the Tax (as % of total tax revenue) of Ukraine in 2011?
Keep it short and to the point. 29.91. What is the average Tax (as % of total tax revenue) in Australia per year?
Offer a very short reply. 71.69. What is the average Tax (as % of total tax revenue) in El Salvador per year?
Provide a succinct answer. 34.78. What is the average Tax (as % of total tax revenue) of South Africa per year?
Keep it short and to the point. 56.84. What is the average Tax (as % of total tax revenue) of Ukraine per year?
Make the answer very short. 26.59. In the year 2005, what is the difference between the Tax (as % of total tax revenue) in Australia and Tax (as % of total tax revenue) in El Salvador?
Give a very brief answer. 40.06. In the year 2005, what is the difference between the Tax (as % of total tax revenue) in Australia and Tax (as % of total tax revenue) in South Africa?
Provide a succinct answer. 16.43. In the year 2005, what is the difference between the Tax (as % of total tax revenue) in Australia and Tax (as % of total tax revenue) in Ukraine?
Ensure brevity in your answer.  39.23. In the year 2005, what is the difference between the Tax (as % of total tax revenue) of El Salvador and Tax (as % of total tax revenue) of South Africa?
Make the answer very short. -23.62. In the year 2005, what is the difference between the Tax (as % of total tax revenue) in El Salvador and Tax (as % of total tax revenue) in Ukraine?
Your answer should be very brief. -0.82. In the year 2005, what is the difference between the Tax (as % of total tax revenue) in South Africa and Tax (as % of total tax revenue) in Ukraine?
Your answer should be compact. 22.8. In the year 2006, what is the difference between the Tax (as % of total tax revenue) in Australia and Tax (as % of total tax revenue) in El Salvador?
Your answer should be compact. 39.31. In the year 2006, what is the difference between the Tax (as % of total tax revenue) of Australia and Tax (as % of total tax revenue) of South Africa?
Give a very brief answer. 16.03. In the year 2006, what is the difference between the Tax (as % of total tax revenue) of Australia and Tax (as % of total tax revenue) of Ukraine?
Give a very brief answer. 45.07. In the year 2006, what is the difference between the Tax (as % of total tax revenue) in El Salvador and Tax (as % of total tax revenue) in South Africa?
Provide a succinct answer. -23.28. In the year 2006, what is the difference between the Tax (as % of total tax revenue) in El Salvador and Tax (as % of total tax revenue) in Ukraine?
Keep it short and to the point. 5.76. In the year 2006, what is the difference between the Tax (as % of total tax revenue) of South Africa and Tax (as % of total tax revenue) of Ukraine?
Your answer should be compact. 29.04. In the year 2007, what is the difference between the Tax (as % of total tax revenue) of Australia and Tax (as % of total tax revenue) of El Salvador?
Your answer should be compact. 38.4. In the year 2007, what is the difference between the Tax (as % of total tax revenue) of Australia and Tax (as % of total tax revenue) of South Africa?
Ensure brevity in your answer.  15.24. In the year 2007, what is the difference between the Tax (as % of total tax revenue) of Australia and Tax (as % of total tax revenue) of Ukraine?
Make the answer very short. 43.7. In the year 2007, what is the difference between the Tax (as % of total tax revenue) of El Salvador and Tax (as % of total tax revenue) of South Africa?
Ensure brevity in your answer.  -23.16. In the year 2007, what is the difference between the Tax (as % of total tax revenue) in El Salvador and Tax (as % of total tax revenue) in Ukraine?
Keep it short and to the point. 5.29. In the year 2007, what is the difference between the Tax (as % of total tax revenue) in South Africa and Tax (as % of total tax revenue) in Ukraine?
Ensure brevity in your answer.  28.45. In the year 2008, what is the difference between the Tax (as % of total tax revenue) of Australia and Tax (as % of total tax revenue) of El Salvador?
Make the answer very short. 38.8. In the year 2008, what is the difference between the Tax (as % of total tax revenue) in Australia and Tax (as % of total tax revenue) in South Africa?
Provide a short and direct response. 12.64. In the year 2008, what is the difference between the Tax (as % of total tax revenue) in Australia and Tax (as % of total tax revenue) in Ukraine?
Your response must be concise. 44.99. In the year 2008, what is the difference between the Tax (as % of total tax revenue) of El Salvador and Tax (as % of total tax revenue) of South Africa?
Ensure brevity in your answer.  -26.16. In the year 2008, what is the difference between the Tax (as % of total tax revenue) of El Salvador and Tax (as % of total tax revenue) of Ukraine?
Ensure brevity in your answer.  6.19. In the year 2008, what is the difference between the Tax (as % of total tax revenue) in South Africa and Tax (as % of total tax revenue) in Ukraine?
Provide a short and direct response. 32.35. In the year 2009, what is the difference between the Tax (as % of total tax revenue) of Australia and Tax (as % of total tax revenue) of El Salvador?
Offer a terse response. 34.61. In the year 2009, what is the difference between the Tax (as % of total tax revenue) in Australia and Tax (as % of total tax revenue) in South Africa?
Offer a terse response. 13.75. In the year 2009, what is the difference between the Tax (as % of total tax revenue) in Australia and Tax (as % of total tax revenue) in Ukraine?
Offer a very short reply. 50.65. In the year 2009, what is the difference between the Tax (as % of total tax revenue) in El Salvador and Tax (as % of total tax revenue) in South Africa?
Offer a terse response. -20.86. In the year 2009, what is the difference between the Tax (as % of total tax revenue) in El Salvador and Tax (as % of total tax revenue) in Ukraine?
Provide a short and direct response. 16.05. In the year 2009, what is the difference between the Tax (as % of total tax revenue) of South Africa and Tax (as % of total tax revenue) of Ukraine?
Your response must be concise. 36.91. In the year 2010, what is the difference between the Tax (as % of total tax revenue) of Australia and Tax (as % of total tax revenue) of El Salvador?
Provide a short and direct response. 34.23. In the year 2010, what is the difference between the Tax (as % of total tax revenue) of Australia and Tax (as % of total tax revenue) of South Africa?
Keep it short and to the point. 14.78. In the year 2010, what is the difference between the Tax (as % of total tax revenue) of Australia and Tax (as % of total tax revenue) of Ukraine?
Ensure brevity in your answer.  46.21. In the year 2010, what is the difference between the Tax (as % of total tax revenue) in El Salvador and Tax (as % of total tax revenue) in South Africa?
Your answer should be compact. -19.44. In the year 2010, what is the difference between the Tax (as % of total tax revenue) in El Salvador and Tax (as % of total tax revenue) in Ukraine?
Make the answer very short. 11.99. In the year 2010, what is the difference between the Tax (as % of total tax revenue) of South Africa and Tax (as % of total tax revenue) of Ukraine?
Your answer should be very brief. 31.43. In the year 2011, what is the difference between the Tax (as % of total tax revenue) in Australia and Tax (as % of total tax revenue) in El Salvador?
Ensure brevity in your answer.  32.97. In the year 2011, what is the difference between the Tax (as % of total tax revenue) in Australia and Tax (as % of total tax revenue) in South Africa?
Give a very brief answer. 15.09. In the year 2011, what is the difference between the Tax (as % of total tax revenue) of Australia and Tax (as % of total tax revenue) of Ukraine?
Keep it short and to the point. 45.84. In the year 2011, what is the difference between the Tax (as % of total tax revenue) of El Salvador and Tax (as % of total tax revenue) of South Africa?
Keep it short and to the point. -17.88. In the year 2011, what is the difference between the Tax (as % of total tax revenue) in El Salvador and Tax (as % of total tax revenue) in Ukraine?
Your answer should be very brief. 12.87. In the year 2011, what is the difference between the Tax (as % of total tax revenue) of South Africa and Tax (as % of total tax revenue) of Ukraine?
Provide a succinct answer. 30.75. What is the ratio of the Tax (as % of total tax revenue) in Australia in 2005 to that in 2006?
Your answer should be very brief. 0.99. What is the ratio of the Tax (as % of total tax revenue) of El Salvador in 2005 to that in 2006?
Provide a succinct answer. 0.95. What is the ratio of the Tax (as % of total tax revenue) of South Africa in 2005 to that in 2006?
Make the answer very short. 0.98. What is the ratio of the Tax (as % of total tax revenue) in Ukraine in 2005 to that in 2006?
Keep it short and to the point. 1.19. What is the ratio of the Tax (as % of total tax revenue) in El Salvador in 2005 to that in 2007?
Provide a short and direct response. 0.92. What is the ratio of the Tax (as % of total tax revenue) of South Africa in 2005 to that in 2007?
Your response must be concise. 0.96. What is the ratio of the Tax (as % of total tax revenue) of Ukraine in 2005 to that in 2007?
Give a very brief answer. 1.12. What is the ratio of the Tax (as % of total tax revenue) in Australia in 2005 to that in 2008?
Offer a terse response. 0.97. What is the ratio of the Tax (as % of total tax revenue) in El Salvador in 2005 to that in 2008?
Make the answer very short. 0.91. What is the ratio of the Tax (as % of total tax revenue) of South Africa in 2005 to that in 2008?
Your response must be concise. 0.91. What is the ratio of the Tax (as % of total tax revenue) in Ukraine in 2005 to that in 2008?
Ensure brevity in your answer.  1.14. What is the ratio of the Tax (as % of total tax revenue) in Australia in 2005 to that in 2009?
Your response must be concise. 0.98. What is the ratio of the Tax (as % of total tax revenue) in El Salvador in 2005 to that in 2009?
Give a very brief answer. 0.82. What is the ratio of the Tax (as % of total tax revenue) of South Africa in 2005 to that in 2009?
Your response must be concise. 0.93. What is the ratio of the Tax (as % of total tax revenue) of Ukraine in 2005 to that in 2009?
Offer a very short reply. 1.46. What is the ratio of the Tax (as % of total tax revenue) in Australia in 2005 to that in 2010?
Provide a succinct answer. 1.02. What is the ratio of the Tax (as % of total tax revenue) of El Salvador in 2005 to that in 2010?
Ensure brevity in your answer.  0.87. What is the ratio of the Tax (as % of total tax revenue) of South Africa in 2005 to that in 2010?
Offer a very short reply. 0.99. What is the ratio of the Tax (as % of total tax revenue) of Ukraine in 2005 to that in 2010?
Provide a succinct answer. 1.34. What is the ratio of the Tax (as % of total tax revenue) of El Salvador in 2005 to that in 2011?
Keep it short and to the point. 0.81. What is the ratio of the Tax (as % of total tax revenue) in South Africa in 2005 to that in 2011?
Give a very brief answer. 0.98. What is the ratio of the Tax (as % of total tax revenue) of Ukraine in 2005 to that in 2011?
Make the answer very short. 1.26. What is the ratio of the Tax (as % of total tax revenue) in Australia in 2006 to that in 2007?
Offer a terse response. 0.99. What is the ratio of the Tax (as % of total tax revenue) in El Salvador in 2006 to that in 2007?
Ensure brevity in your answer.  0.96. What is the ratio of the Tax (as % of total tax revenue) in South Africa in 2006 to that in 2007?
Ensure brevity in your answer.  0.98. What is the ratio of the Tax (as % of total tax revenue) of Ukraine in 2006 to that in 2007?
Your answer should be compact. 0.94. What is the ratio of the Tax (as % of total tax revenue) in Australia in 2006 to that in 2008?
Give a very brief answer. 0.98. What is the ratio of the Tax (as % of total tax revenue) in El Salvador in 2006 to that in 2008?
Your answer should be very brief. 0.95. What is the ratio of the Tax (as % of total tax revenue) in South Africa in 2006 to that in 2008?
Your answer should be very brief. 0.92. What is the ratio of the Tax (as % of total tax revenue) of Ukraine in 2006 to that in 2008?
Provide a succinct answer. 0.96. What is the ratio of the Tax (as % of total tax revenue) in Australia in 2006 to that in 2009?
Your response must be concise. 0.99. What is the ratio of the Tax (as % of total tax revenue) in El Salvador in 2006 to that in 2009?
Offer a very short reply. 0.86. What is the ratio of the Tax (as % of total tax revenue) in South Africa in 2006 to that in 2009?
Your response must be concise. 0.95. What is the ratio of the Tax (as % of total tax revenue) of Ukraine in 2006 to that in 2009?
Your answer should be compact. 1.23. What is the ratio of the Tax (as % of total tax revenue) of Australia in 2006 to that in 2010?
Ensure brevity in your answer.  1.03. What is the ratio of the Tax (as % of total tax revenue) in El Salvador in 2006 to that in 2010?
Give a very brief answer. 0.91. What is the ratio of the Tax (as % of total tax revenue) in Ukraine in 2006 to that in 2010?
Offer a terse response. 1.13. What is the ratio of the Tax (as % of total tax revenue) in Australia in 2006 to that in 2011?
Your response must be concise. 1.01. What is the ratio of the Tax (as % of total tax revenue) of El Salvador in 2006 to that in 2011?
Make the answer very short. 0.85. What is the ratio of the Tax (as % of total tax revenue) in South Africa in 2006 to that in 2011?
Keep it short and to the point. 1. What is the ratio of the Tax (as % of total tax revenue) in Ukraine in 2006 to that in 2011?
Your response must be concise. 1.06. What is the ratio of the Tax (as % of total tax revenue) in El Salvador in 2007 to that in 2008?
Provide a succinct answer. 0.99. What is the ratio of the Tax (as % of total tax revenue) in South Africa in 2007 to that in 2008?
Give a very brief answer. 0.94. What is the ratio of the Tax (as % of total tax revenue) of Ukraine in 2007 to that in 2008?
Offer a very short reply. 1.02. What is the ratio of the Tax (as % of total tax revenue) in Australia in 2007 to that in 2009?
Your answer should be compact. 1. What is the ratio of the Tax (as % of total tax revenue) in El Salvador in 2007 to that in 2009?
Make the answer very short. 0.9. What is the ratio of the Tax (as % of total tax revenue) in South Africa in 2007 to that in 2009?
Offer a very short reply. 0.97. What is the ratio of the Tax (as % of total tax revenue) in Ukraine in 2007 to that in 2009?
Your answer should be very brief. 1.31. What is the ratio of the Tax (as % of total tax revenue) in Australia in 2007 to that in 2010?
Give a very brief answer. 1.03. What is the ratio of the Tax (as % of total tax revenue) of El Salvador in 2007 to that in 2010?
Provide a succinct answer. 0.95. What is the ratio of the Tax (as % of total tax revenue) in South Africa in 2007 to that in 2010?
Ensure brevity in your answer.  1.03. What is the ratio of the Tax (as % of total tax revenue) in Ukraine in 2007 to that in 2010?
Give a very brief answer. 1.2. What is the ratio of the Tax (as % of total tax revenue) in Australia in 2007 to that in 2011?
Offer a terse response. 1.02. What is the ratio of the Tax (as % of total tax revenue) of El Salvador in 2007 to that in 2011?
Make the answer very short. 0.89. What is the ratio of the Tax (as % of total tax revenue) of South Africa in 2007 to that in 2011?
Ensure brevity in your answer.  1.02. What is the ratio of the Tax (as % of total tax revenue) of Ukraine in 2007 to that in 2011?
Provide a succinct answer. 1.13. What is the ratio of the Tax (as % of total tax revenue) in Australia in 2008 to that in 2009?
Your response must be concise. 1.01. What is the ratio of the Tax (as % of total tax revenue) of El Salvador in 2008 to that in 2009?
Make the answer very short. 0.9. What is the ratio of the Tax (as % of total tax revenue) in South Africa in 2008 to that in 2009?
Make the answer very short. 1.03. What is the ratio of the Tax (as % of total tax revenue) of Ukraine in 2008 to that in 2009?
Keep it short and to the point. 1.29. What is the ratio of the Tax (as % of total tax revenue) of Australia in 2008 to that in 2010?
Make the answer very short. 1.04. What is the ratio of the Tax (as % of total tax revenue) of El Salvador in 2008 to that in 2010?
Provide a short and direct response. 0.96. What is the ratio of the Tax (as % of total tax revenue) in South Africa in 2008 to that in 2010?
Ensure brevity in your answer.  1.09. What is the ratio of the Tax (as % of total tax revenue) in Ukraine in 2008 to that in 2010?
Offer a terse response. 1.18. What is the ratio of the Tax (as % of total tax revenue) in Australia in 2008 to that in 2011?
Your answer should be very brief. 1.03. What is the ratio of the Tax (as % of total tax revenue) of El Salvador in 2008 to that in 2011?
Keep it short and to the point. 0.9. What is the ratio of the Tax (as % of total tax revenue) in South Africa in 2008 to that in 2011?
Provide a short and direct response. 1.08. What is the ratio of the Tax (as % of total tax revenue) in Ukraine in 2008 to that in 2011?
Make the answer very short. 1.11. What is the ratio of the Tax (as % of total tax revenue) in Australia in 2009 to that in 2010?
Provide a succinct answer. 1.03. What is the ratio of the Tax (as % of total tax revenue) in El Salvador in 2009 to that in 2010?
Offer a very short reply. 1.06. What is the ratio of the Tax (as % of total tax revenue) of South Africa in 2009 to that in 2010?
Your response must be concise. 1.06. What is the ratio of the Tax (as % of total tax revenue) in Ukraine in 2009 to that in 2010?
Make the answer very short. 0.92. What is the ratio of the Tax (as % of total tax revenue) in Australia in 2009 to that in 2011?
Provide a succinct answer. 1.02. What is the ratio of the Tax (as % of total tax revenue) in South Africa in 2009 to that in 2011?
Give a very brief answer. 1.05. What is the ratio of the Tax (as % of total tax revenue) in Ukraine in 2009 to that in 2011?
Give a very brief answer. 0.86. What is the ratio of the Tax (as % of total tax revenue) in El Salvador in 2010 to that in 2011?
Give a very brief answer. 0.94. What is the ratio of the Tax (as % of total tax revenue) in South Africa in 2010 to that in 2011?
Your answer should be very brief. 0.98. What is the ratio of the Tax (as % of total tax revenue) in Ukraine in 2010 to that in 2011?
Provide a short and direct response. 0.94. What is the difference between the highest and the second highest Tax (as % of total tax revenue) in Australia?
Make the answer very short. 0.58. What is the difference between the highest and the second highest Tax (as % of total tax revenue) in El Salvador?
Make the answer very short. 0.34. What is the difference between the highest and the second highest Tax (as % of total tax revenue) of South Africa?
Provide a short and direct response. 1.68. What is the difference between the highest and the second highest Tax (as % of total tax revenue) in Ukraine?
Give a very brief answer. 3.31. What is the difference between the highest and the lowest Tax (as % of total tax revenue) of Australia?
Offer a terse response. 3.01. What is the difference between the highest and the lowest Tax (as % of total tax revenue) in El Salvador?
Provide a succinct answer. 7.1. What is the difference between the highest and the lowest Tax (as % of total tax revenue) of South Africa?
Your answer should be very brief. 5.68. What is the difference between the highest and the lowest Tax (as % of total tax revenue) in Ukraine?
Your answer should be very brief. 10.12. 